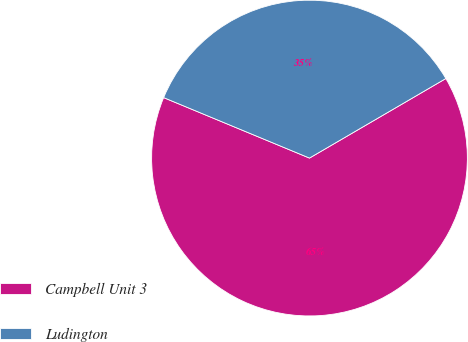Convert chart to OTSL. <chart><loc_0><loc_0><loc_500><loc_500><pie_chart><fcel>Campbell Unit 3<fcel>Ludington<nl><fcel>64.66%<fcel>35.34%<nl></chart> 